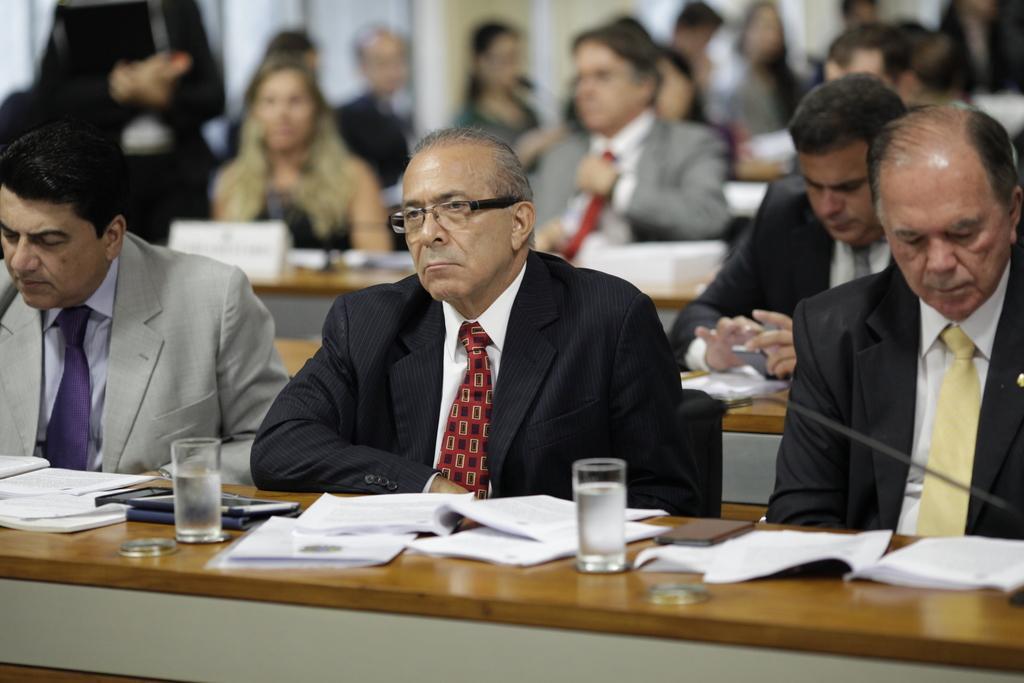In one or two sentences, can you explain what this image depicts? In this picture we can see some people are sitting, in front we can see the table, on which we can see some objects like, book, mobile, glasses. 